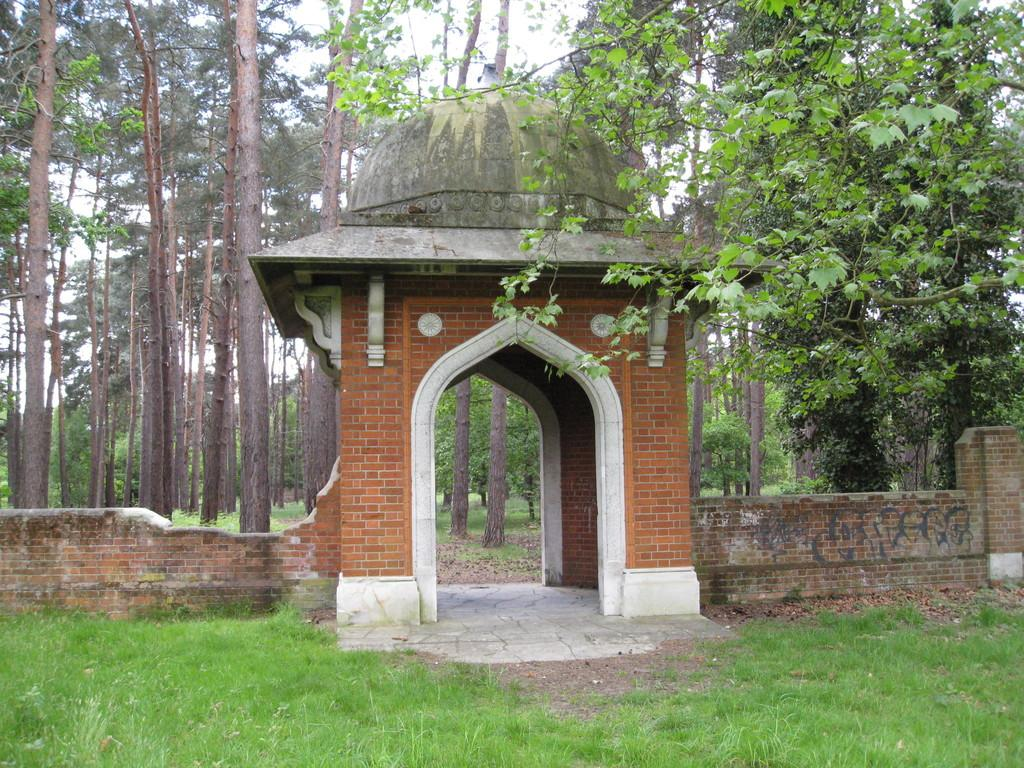What structure is located in the middle of the image? There is an arch in the middle of the image. What material is used to construct the wall beside the arch? The wall beside the arch is made up of bricks. What type of vegetation is visible at the bottom of the image? Grass is visible at the bottom of the image. What can be seen in the background of the image? There are trees in the background of the image. Can you see a leg sticking out from under the arch in the image? There is no leg visible in the image; it features an arch, a brick wall, grass, and trees. Is there a battle taking place in the image? There is no battle depicted in the image; it shows an arch, a brick wall, grass, and trees. 